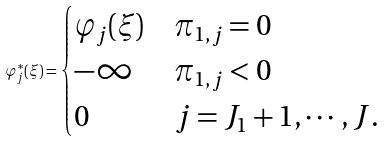<formula> <loc_0><loc_0><loc_500><loc_500>\varphi ^ { * } _ { j } ( \xi ) = \begin{cases} \varphi _ { j } ( \xi ) & \pi _ { 1 , j } = 0 \\ - \infty & \pi _ { 1 , j } < 0 \\ 0 & j = J _ { 1 } + 1 , \cdots , J . \end{cases}</formula> 